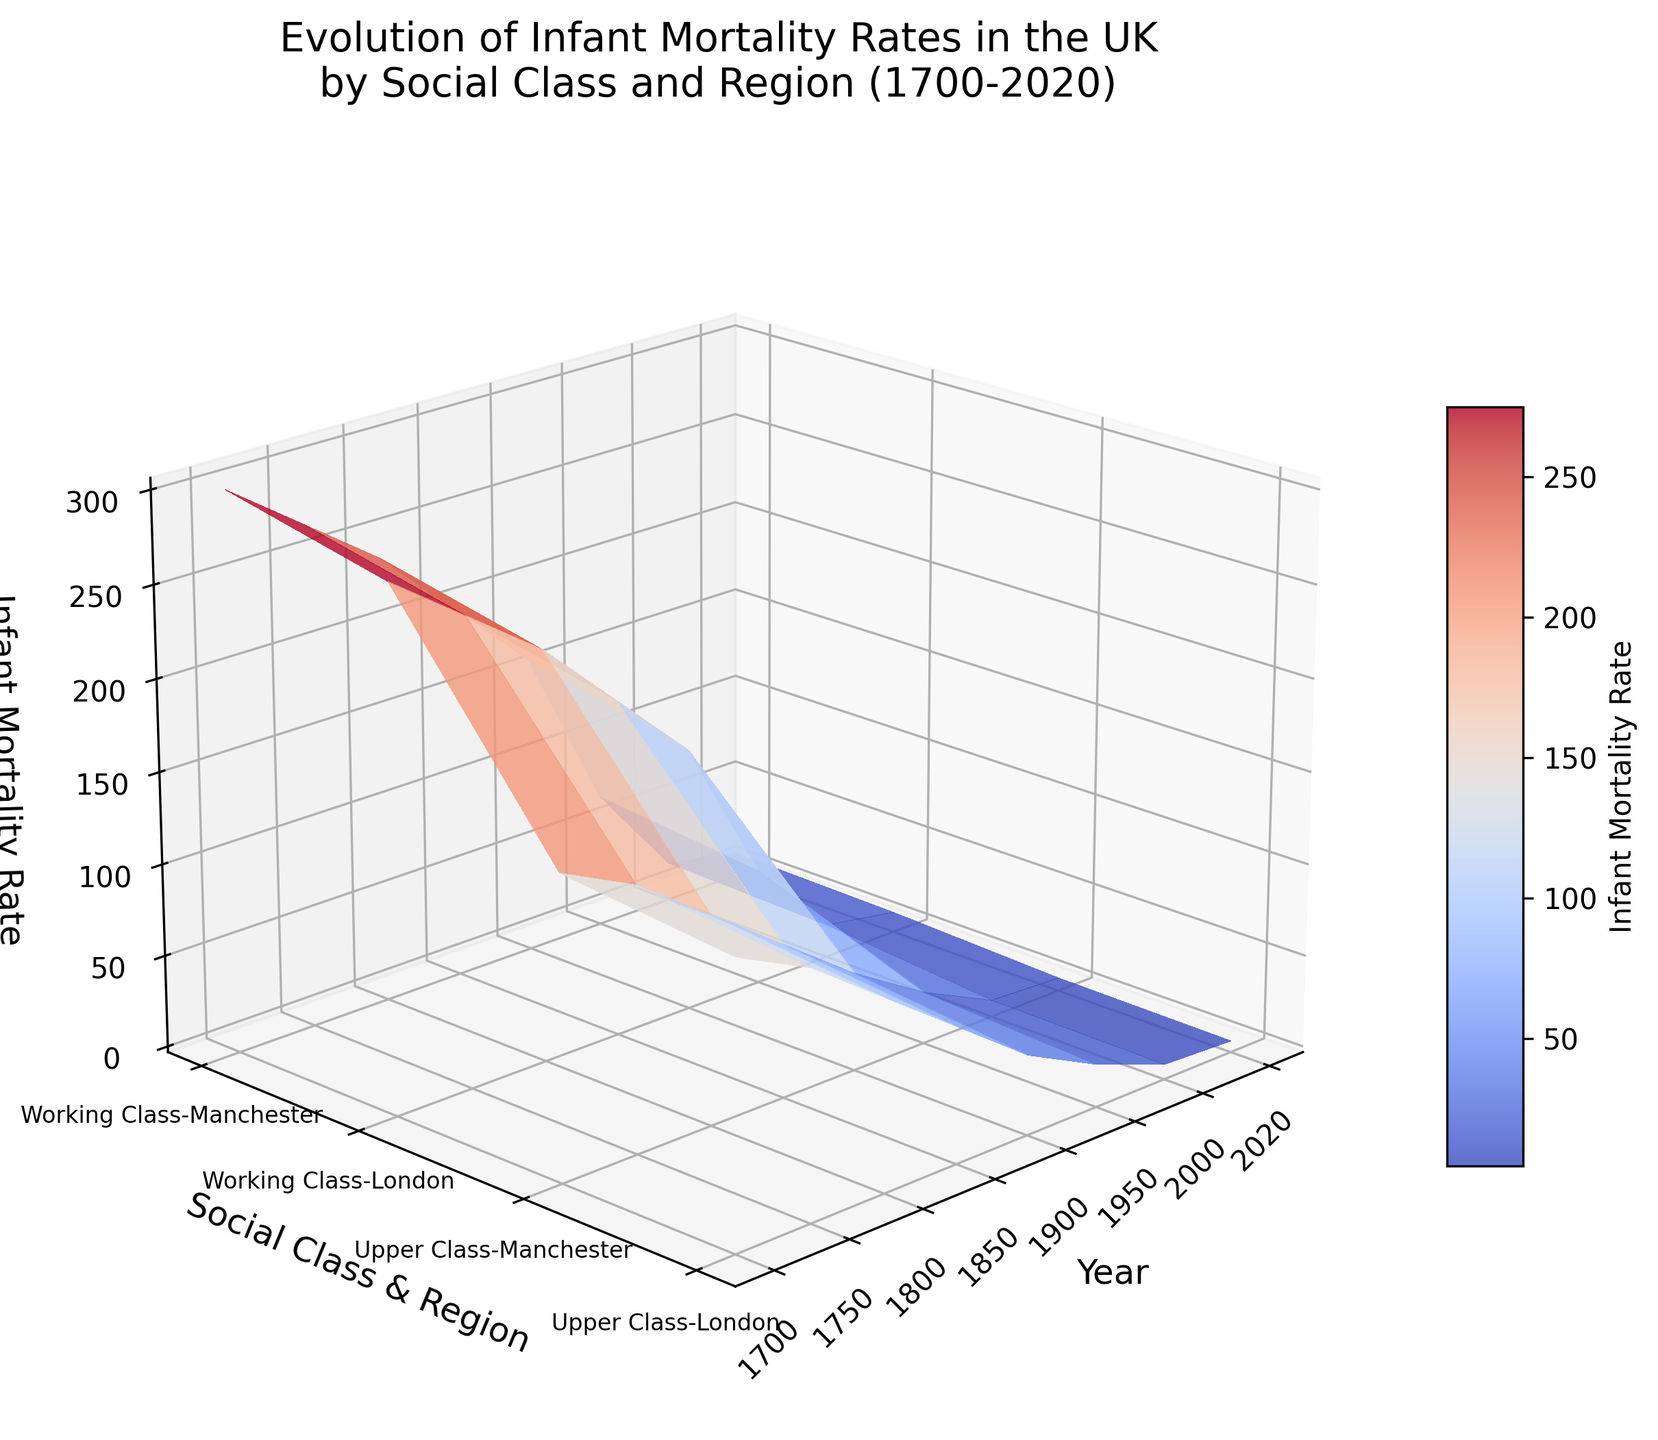When does the infant mortality rate in London for the upper class first drop below 50? The figure shows infant mortality rates over time, making it easy to track specific trends for cities and classes. Look for the point where the upper class in London first dips below 50. This occurs between 1850 and 1900.
Answer: Between 1850 and 1900 What is the lowest infant mortality rate recorded for the working class in Manchester? The plot shows infant mortality rates categorized by class and region. Identify the point on the Manchester curve for the working class with the smallest z-value.
Answer: 10 In which year does Manchester's working class experience an infant mortality rate of around 70? Search for the year along the x-axis where the Manchester working class line intersects z=70. You'll find this year in the proximity of 1950.
Answer: 1950 How do the infant mortality rates compare between the upper class and working class in London in 1700? Locate the values for London in 1700 for both social classes. The upper class has a lower rate (150) compared to the working class (280).
Answer: The upper class rate is lower What region and social class show the most significant reduction in infant mortality rate between 1700 and 2020? Compare the start and end points of the curves for each social class and region to find the largest drop. The working class in Manchester shows a reduction from 300 to 10, a drop of 290, which is the largest.
Answer: Working class in Manchester Between 1800 and 1900, which social class in London saw the greatest improvement in infant mortality rates? Compare the z-values for 1800 and 1900 for both social classes in London. The upper class drops from 100 to 40 (a reduction of 60), while the working class drops from 220 to 140 (a reduction of 80). Therefore, the working class saw a greater improvement.
Answer: Working class In 1750, which city had lower infant mortality rates for the upper class, London or Manchester? Search for the year 1750 and compare the rates for the upper class in both cities. London shows a rate of 130, and Manchester shows 140.
Answer: London By how much did the infant mortality rate for the working class in London decrease from 1850 to 2000? Identify the values for the working class in London for 1850 (180) and 2000 (15). Subtract to find the decrease: 180 - 15 = 165.
Answer: 165 Which social class in Manchester had a higher infant mortality rate in 2020, and by how much was it higher compared to the same class in London? Look at 2020 rates for the working class in both cities. Manchester has a rate of 10, while London has 8, resulting in a difference of 2.
Answer: Working class in Manchester, by 2 How did the infant mortality rate change for the upper class in Manchester from 1700 to 1750? Find the rates in 1700 (160) and 1750 (140) for the upper class in Manchester to see the change: 160 - 140 = 20.
Answer: A decrease of 20 